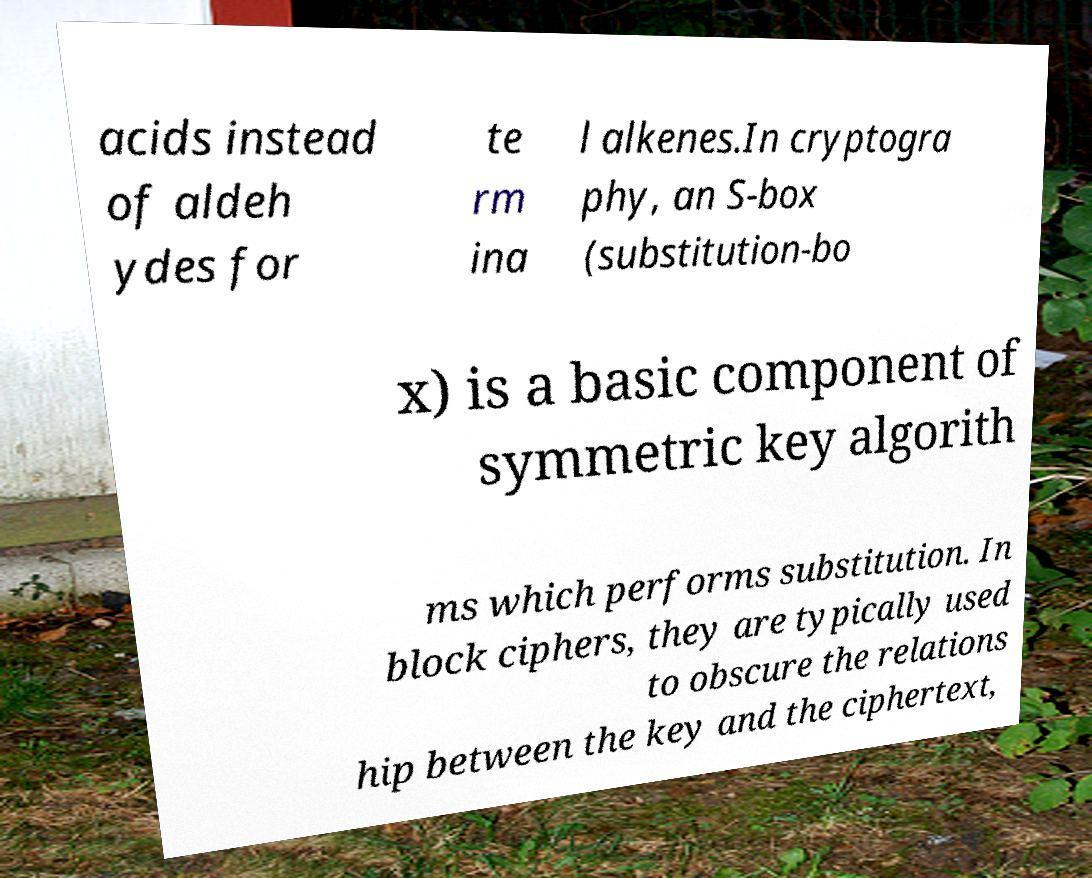For documentation purposes, I need the text within this image transcribed. Could you provide that? acids instead of aldeh ydes for te rm ina l alkenes.In cryptogra phy, an S-box (substitution-bo x) is a basic component of symmetric key algorith ms which performs substitution. In block ciphers, they are typically used to obscure the relations hip between the key and the ciphertext, 